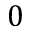Convert formula to latex. <formula><loc_0><loc_0><loc_500><loc_500>0</formula> 